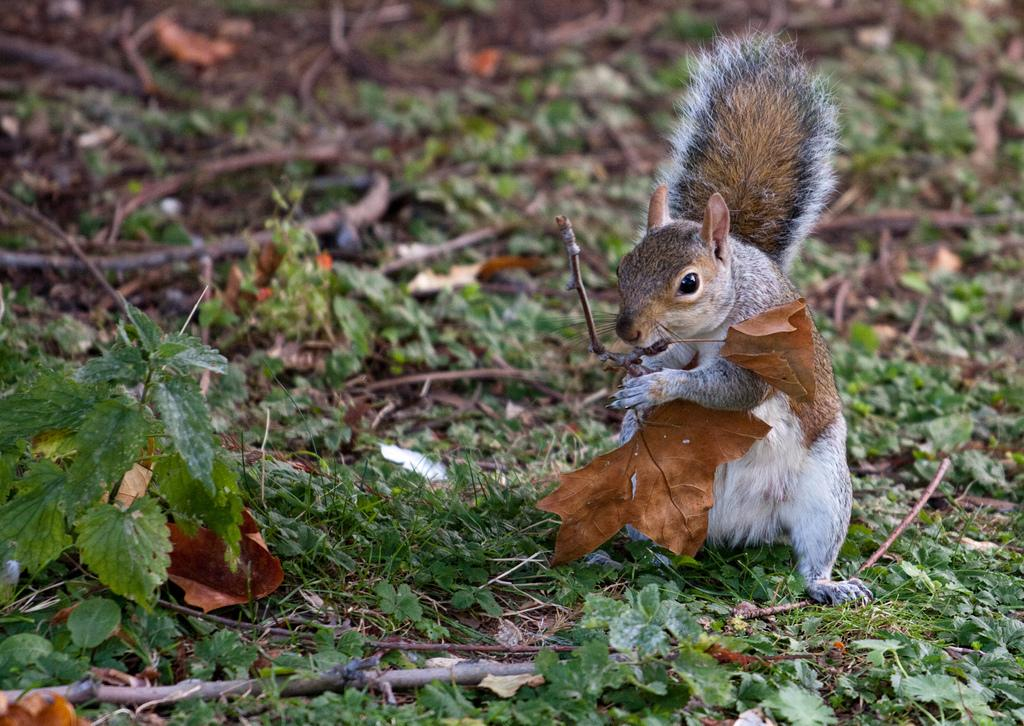What animal can be seen in the image? There is a squirrel in the image. What is the squirrel holding in its mouth? The squirrel is holding a leaf. What type of vegetation is present in the image? There are plants on a path in the image. What type of quince can be seen growing on the path in the image? There is no quince present in the image; only a squirrel and plants are visible. 